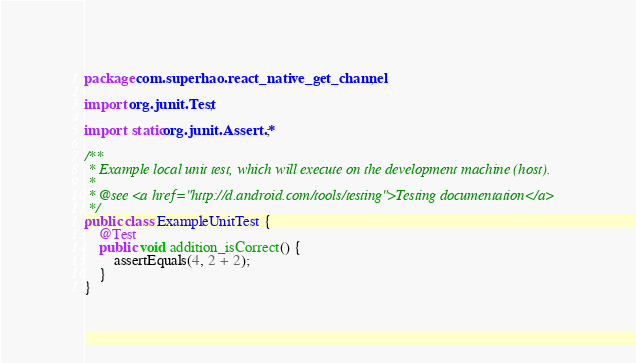Convert code to text. <code><loc_0><loc_0><loc_500><loc_500><_Java_>package com.superhao.react_native_get_channel;

import org.junit.Test;

import static org.junit.Assert.*;

/**
 * Example local unit test, which will execute on the development machine (host).
 *
 * @see <a href="http://d.android.com/tools/testing">Testing documentation</a>
 */
public class ExampleUnitTest {
    @Test
    public void addition_isCorrect() {
        assertEquals(4, 2 + 2);
    }
}</code> 